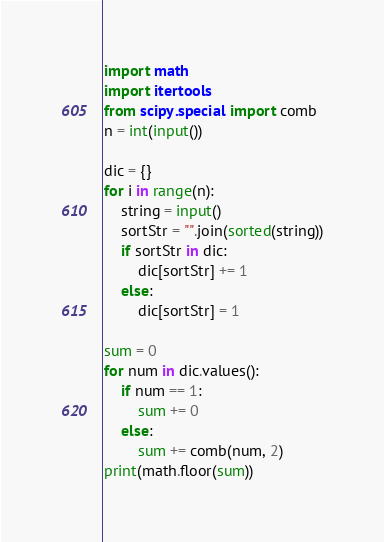Convert code to text. <code><loc_0><loc_0><loc_500><loc_500><_Python_>import math
import itertools
from scipy.special import comb
n = int(input())

dic = {}
for i in range(n):
    string = input()
    sortStr = "".join(sorted(string))
    if sortStr in dic:
        dic[sortStr] += 1
    else:
        dic[sortStr] = 1

sum = 0
for num in dic.values():
    if num == 1:
        sum += 0
    else:
        sum += comb(num, 2)
print(math.floor(sum))</code> 